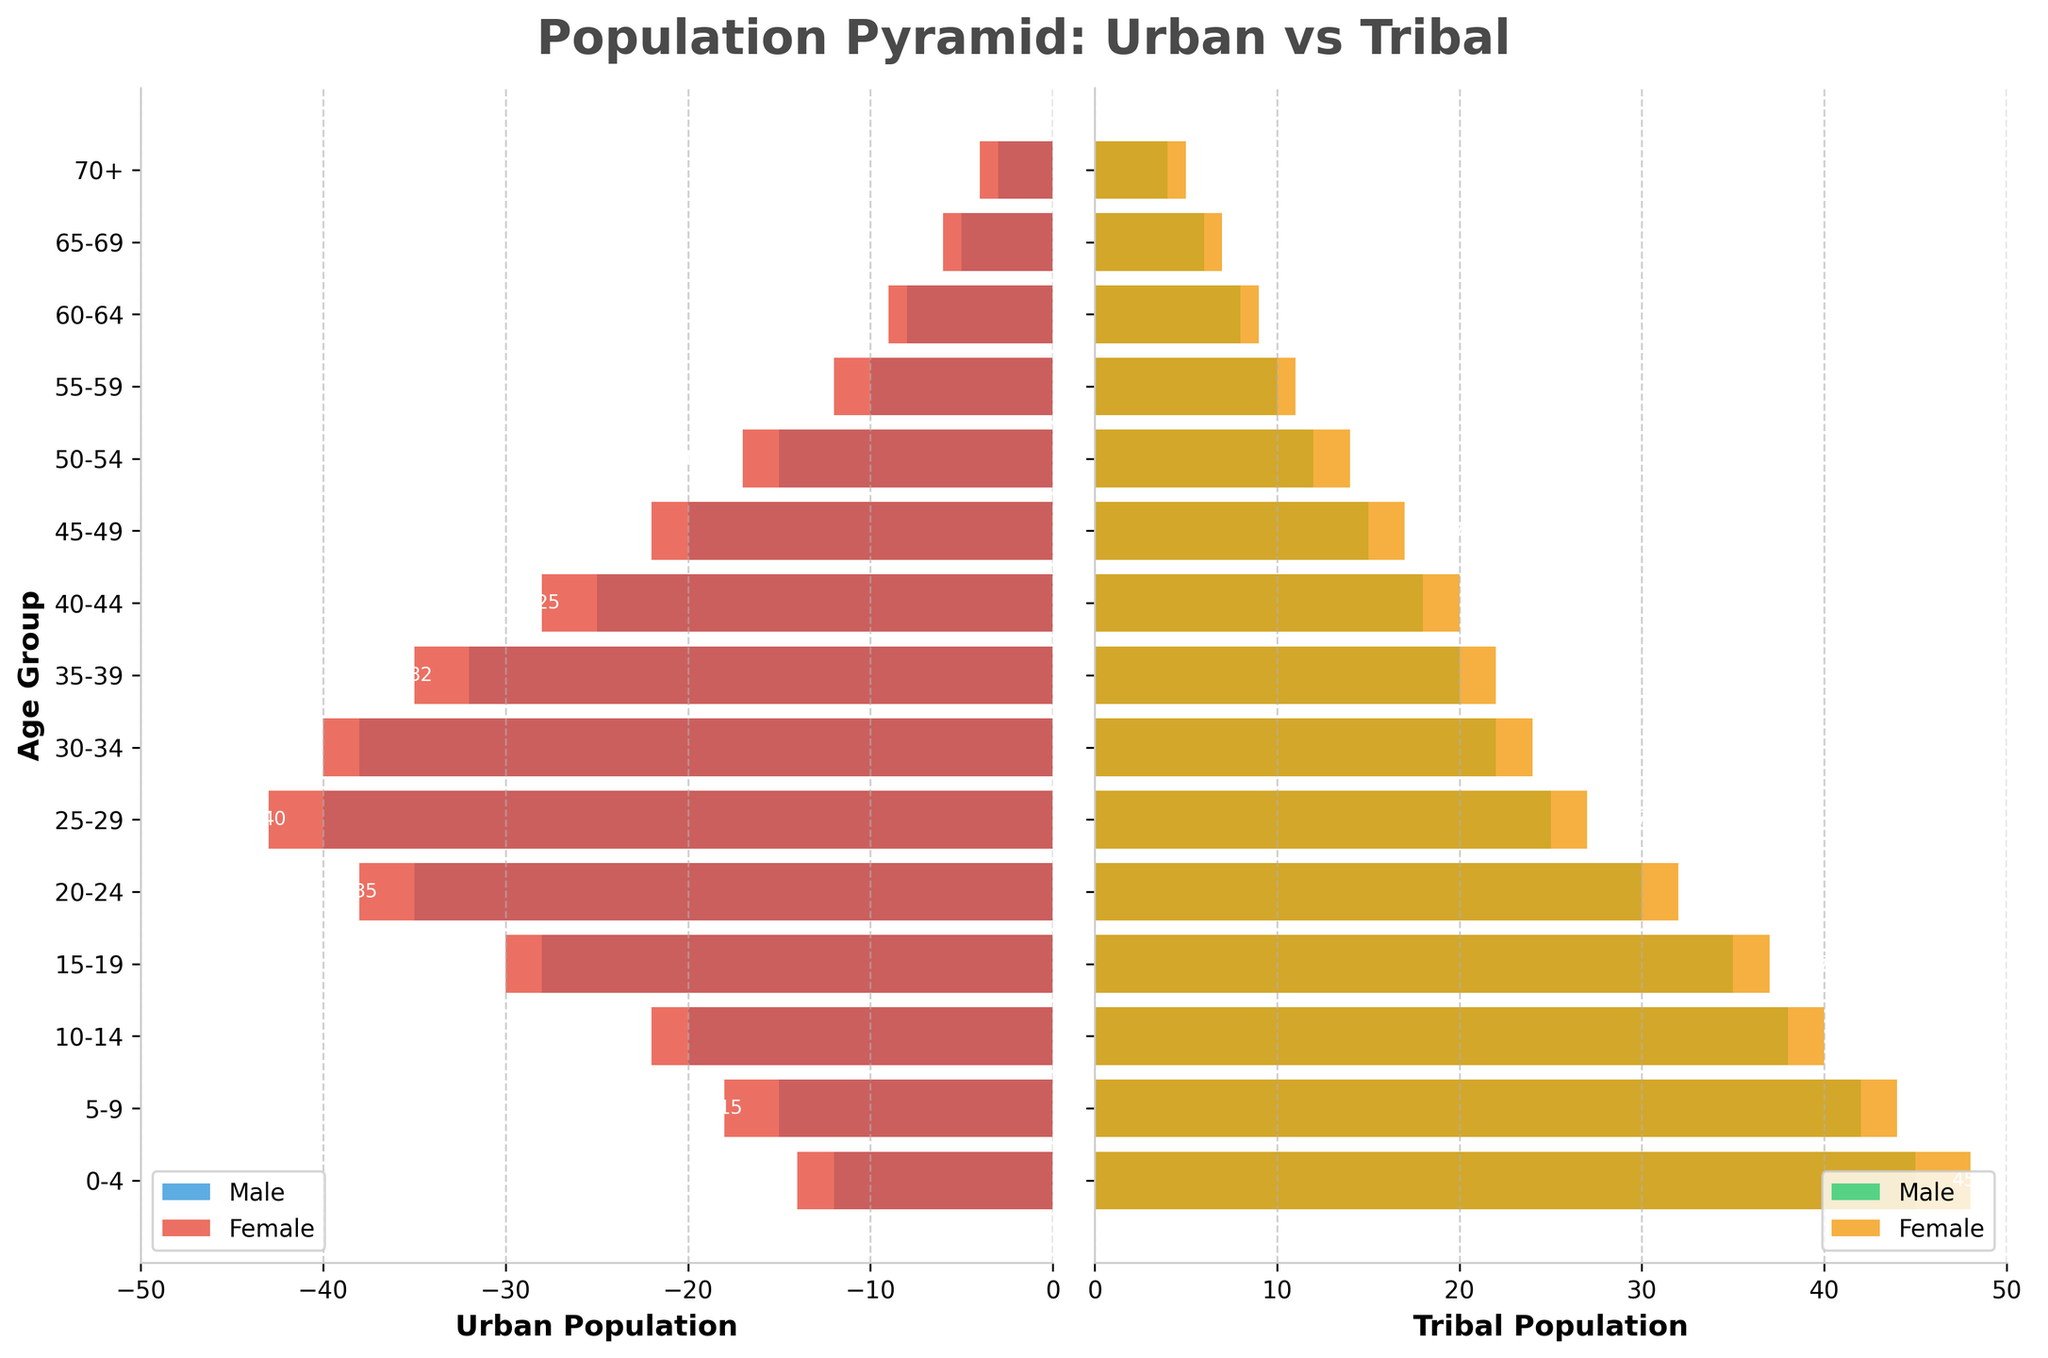What is the title of the figure? The title of the figure is displayed at the top and is usually a brief description of the chart's content. By looking at the top, we can see the title "Population Pyramid: Urban vs Tribal".
Answer: Population Pyramid: Urban vs Tribal What color represents the Male Urban population, and what color represents the Female Urban population? By observing the color of the bars in the Urban population chart, we can see that the Male Urban population is represented by blue bars and the Female Urban population is represented by red bars.
Answer: Male Urban: Blue, Female Urban: Red In the age group 0-4, which population is larger, Male Tribal or Male Urban? By comparing the bars for the 0-4 age group in both charts, we see that the Male Tribal bar is larger than the Male Urban bar. The values are 45 for Male Tribal and 12 for Male Urban.
Answer: Male Tribal How many females aged 25-29 are in the urban areas? We need to look at the Female Urban bar for the age group 25-29. The bar's label indicates there are 43 females in this age group in urban areas.
Answer: 43 What is the total number of males in the 20-24 age group across both populations? We add up the males in the 20-24 age group from both the Urban and Tribal populations. There are 35 Male Urban and 30 Male Tribal, giving a total of 35 + 30 = 65.
Answer: 65 Which age group has the highest number of females in the tribal population? To find the highest number of females, we compare the heights of the Female Tribal bars. The age group 0-4 has the highest number with 48 females.
Answer: 0-4 Compare the populations in the 55-59 age group. Are there more males or females in the Urban population? By comparing the Male Urban and Female Urban bars in the 55-59 age group, we observe that there are 10 males and 12 females, hence females are more.
Answer: Females What is the difference in the number of males aged 30-34 between urban and tribal populations? We calculate the difference by subtracting the Male Tribal number from the Male Urban number in the 30-34 age group: 38 (Urban) - 22 (Tribal) = 16.
Answer: 16 Which group has a smaller population: Males aged 50-54 in urban areas or females aged 50-54 in tribal territories? We compare the values: 15 (Males Urban) and 14 (Females Tribal). Since 14 < 15, females aged 50-54 in tribal territories have a smaller population.
Answer: Females aged 50-54 in tribal territories 